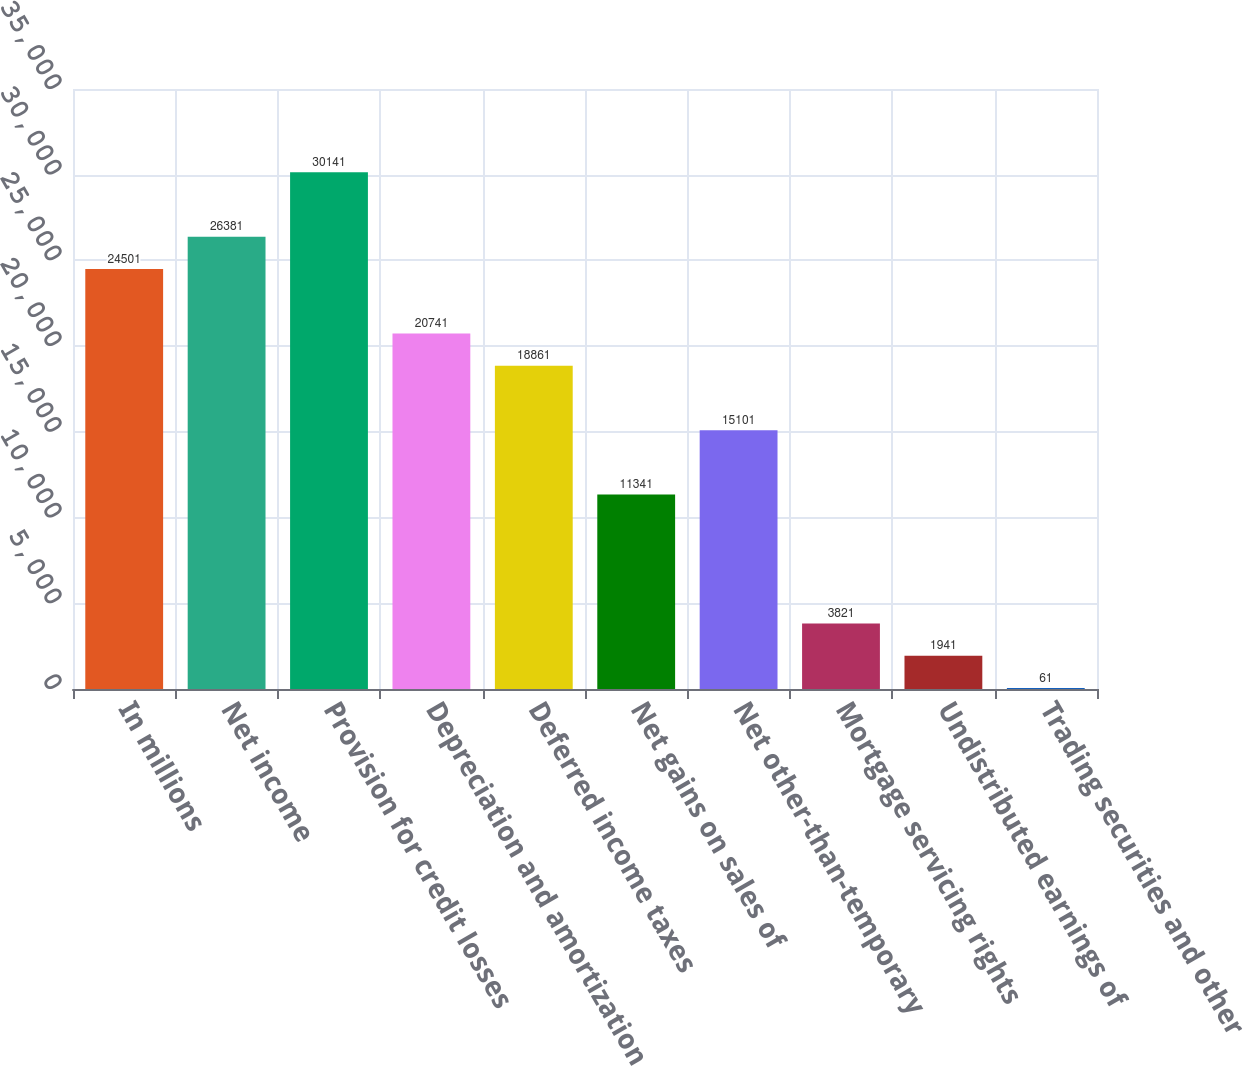<chart> <loc_0><loc_0><loc_500><loc_500><bar_chart><fcel>In millions<fcel>Net income<fcel>Provision for credit losses<fcel>Depreciation and amortization<fcel>Deferred income taxes<fcel>Net gains on sales of<fcel>Net other-than-temporary<fcel>Mortgage servicing rights<fcel>Undistributed earnings of<fcel>Trading securities and other<nl><fcel>24501<fcel>26381<fcel>30141<fcel>20741<fcel>18861<fcel>11341<fcel>15101<fcel>3821<fcel>1941<fcel>61<nl></chart> 